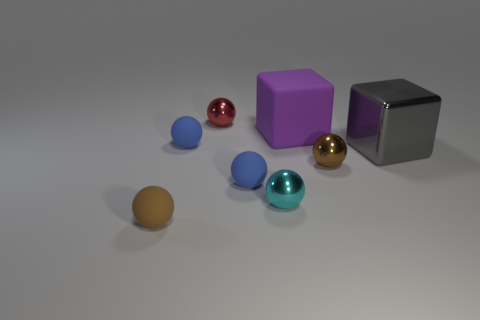What can you infer about the materials of the objects based on their appearance? Based on their appearances, the spheres look like they are made of different materials. The blue and teal spheres have a slightly matte, rubbery texture, while the gold and brown spheres have a reflective, metallic finish. The purple and gray objects are cubes, the purple one with a smoother, possibly plastic surface, and the gray one with a textured, matte finish, reminiscent of brushed metal or stone. 